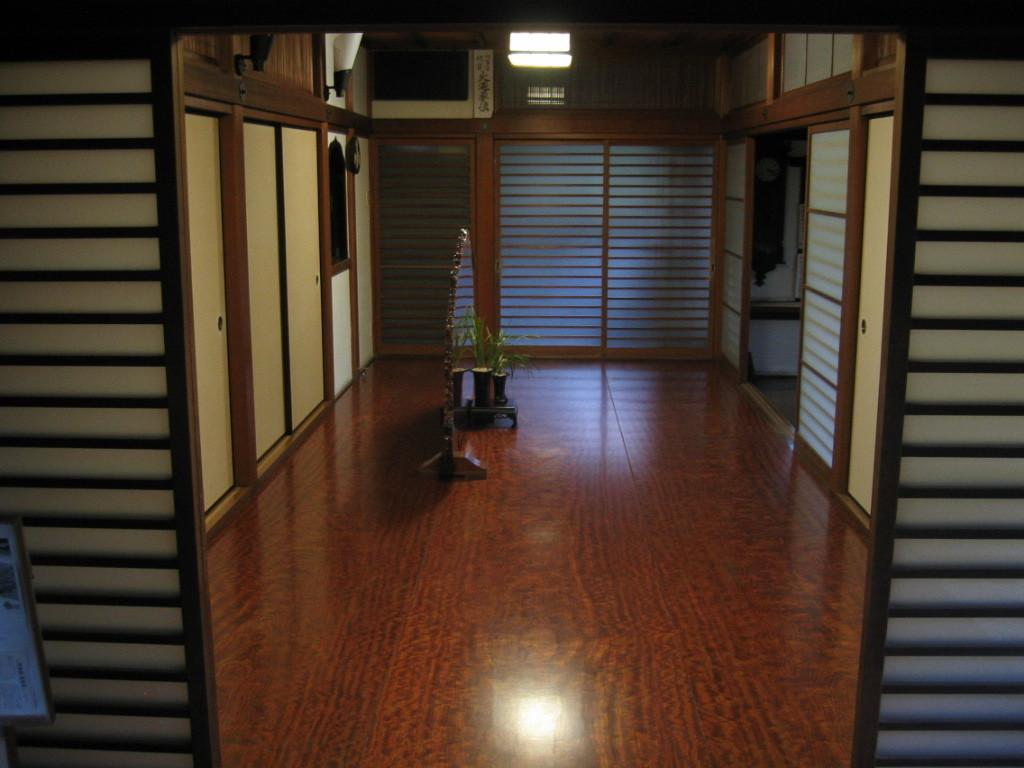What type of setting is shown in the image? The image depicts the interior of a house. What kind of plant can be seen in the image? There is a house plant in the image. Can you describe the lamp in the image? There is a lamp in the image, and it is glowing. How many pies are hanging from the cobweb in the image? There is no cobweb or pies present in the image. 